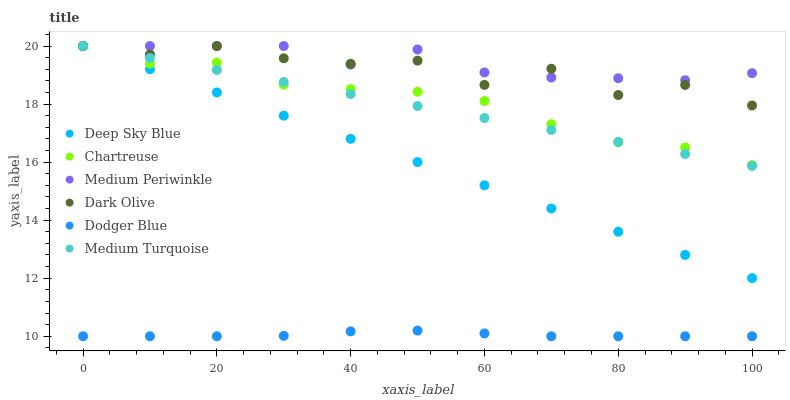Does Dodger Blue have the minimum area under the curve?
Answer yes or no. Yes. Does Medium Periwinkle have the maximum area under the curve?
Answer yes or no. Yes. Does Dark Olive have the minimum area under the curve?
Answer yes or no. No. Does Dark Olive have the maximum area under the curve?
Answer yes or no. No. Is Deep Sky Blue the smoothest?
Answer yes or no. Yes. Is Dark Olive the roughest?
Answer yes or no. Yes. Is Medium Periwinkle the smoothest?
Answer yes or no. No. Is Medium Periwinkle the roughest?
Answer yes or no. No. Does Dodger Blue have the lowest value?
Answer yes or no. Yes. Does Dark Olive have the lowest value?
Answer yes or no. No. Does Medium Turquoise have the highest value?
Answer yes or no. Yes. Does Dodger Blue have the highest value?
Answer yes or no. No. Is Dodger Blue less than Medium Periwinkle?
Answer yes or no. Yes. Is Deep Sky Blue greater than Dodger Blue?
Answer yes or no. Yes. Does Medium Periwinkle intersect Dark Olive?
Answer yes or no. Yes. Is Medium Periwinkle less than Dark Olive?
Answer yes or no. No. Is Medium Periwinkle greater than Dark Olive?
Answer yes or no. No. Does Dodger Blue intersect Medium Periwinkle?
Answer yes or no. No. 